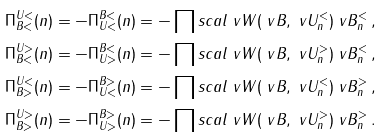Convert formula to latex. <formula><loc_0><loc_0><loc_500><loc_500>\Pi ^ { U < } _ { B < } ( n ) & = - \Pi ^ { B < } _ { U < } ( n ) = - \prod s c a l { \ v W ( \ v B , \ v U ^ { < } _ { n } ) } { \ v B ^ { < } _ { n } } \, , \\ \Pi ^ { U > } _ { B < } ( n ) & = - \Pi ^ { B < } _ { U > } ( n ) = - \prod s c a l { \ v W ( \ v B , \ v U ^ { > } _ { n } ) } { \ v B ^ { < } _ { n } } \, , \\ \Pi ^ { U < } _ { B > } ( n ) & = - \Pi ^ { B > } _ { U < } ( n ) = - \prod s c a l { \ v W ( \ v B , \ v U ^ { < } _ { n } ) } { \ v B ^ { > } _ { n } } \, , \\ \Pi ^ { U > } _ { B > } ( n ) & = - \Pi ^ { B > } _ { U > } ( n ) = - \prod s c a l { \ v W ( \ v B , \ v U ^ { > } _ { n } ) } { \ v B ^ { > } _ { n } } \, .</formula> 